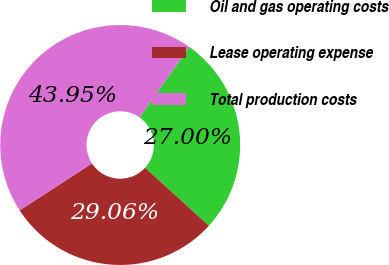<chart> <loc_0><loc_0><loc_500><loc_500><pie_chart><fcel>Oil and gas operating costs<fcel>Lease operating expense<fcel>Total production costs<nl><fcel>27.0%<fcel>29.06%<fcel>43.95%<nl></chart> 